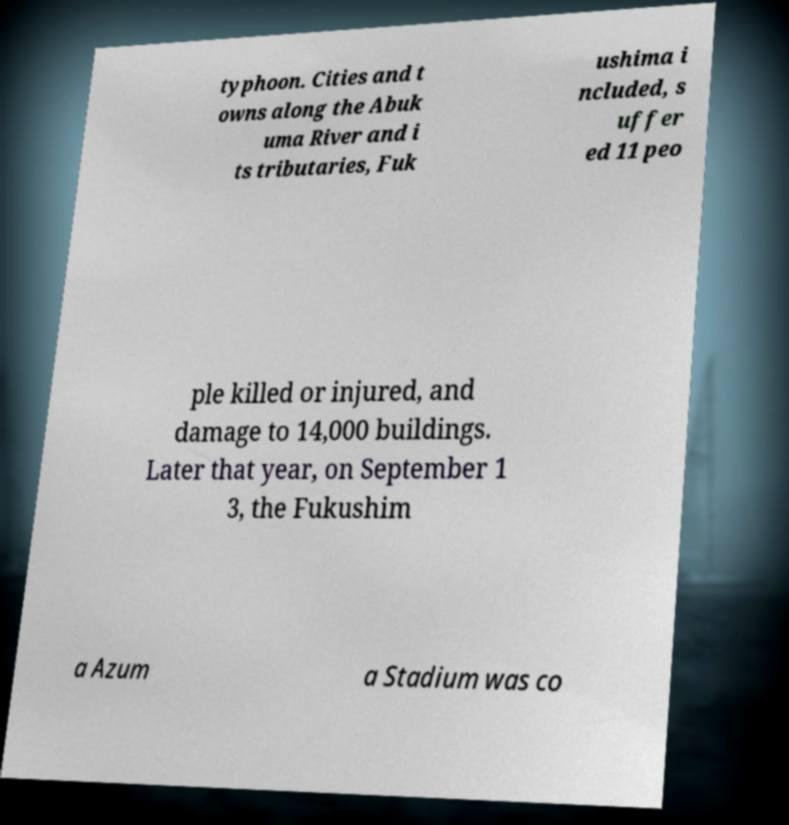Please identify and transcribe the text found in this image. typhoon. Cities and t owns along the Abuk uma River and i ts tributaries, Fuk ushima i ncluded, s uffer ed 11 peo ple killed or injured, and damage to 14,000 buildings. Later that year, on September 1 3, the Fukushim a Azum a Stadium was co 